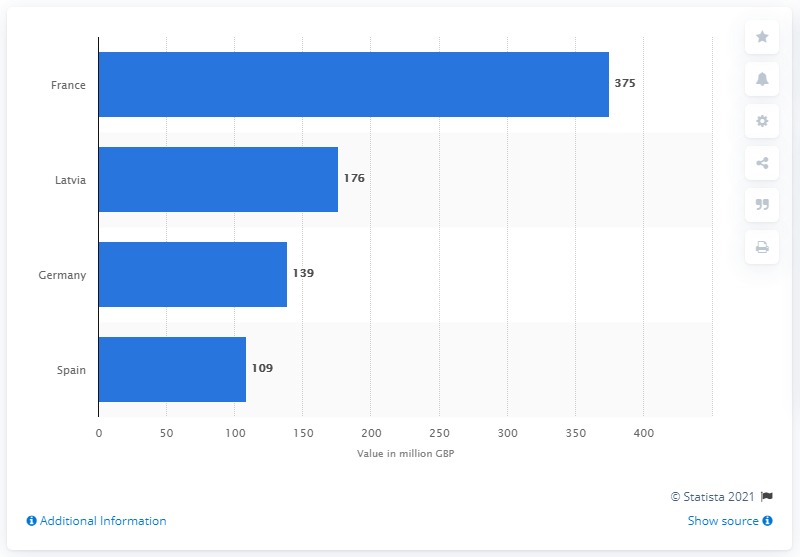List a handful of essential elements in this visual. The leading market for the export of Scotch whisky in 2020 was Latvia. In 2020, the value of Scotch whisky exported to France was 375 million. 